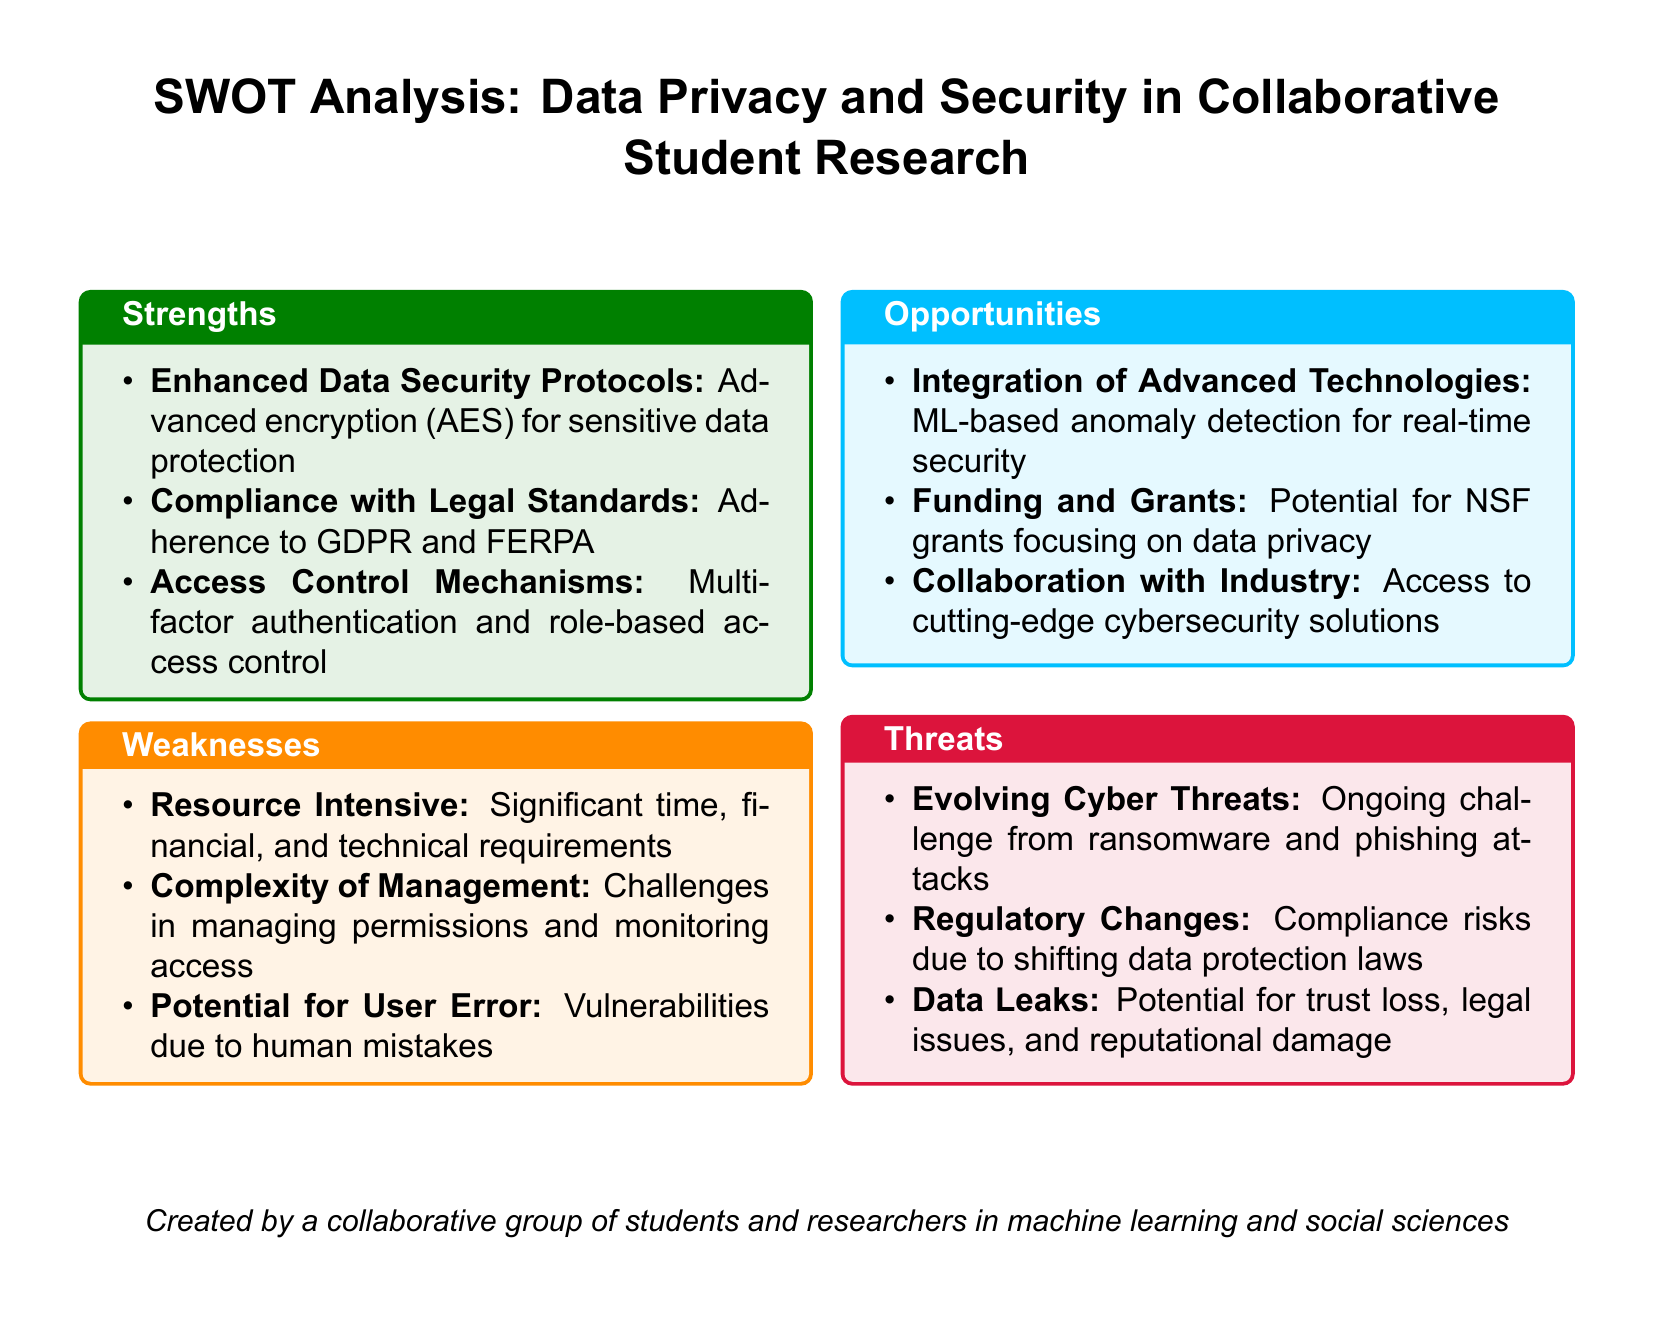what is one of the enhanced data security protocols mentioned? The document lists advanced encryption (AES) as an enhanced data security protocol for sensitive data protection.
Answer: advanced encryption (AES) which two legal standards are mentioned for compliance? The document states adherence to GDPR and FERPA as legal standards.
Answer: GDPR and FERPA what is identified as a potential source of funding? The document mentions potential for NSF grants focusing on data privacy as a funding opportunity.
Answer: NSF grants how are the complexities of management described? It is noted that there are challenges in managing permissions and monitoring access.
Answer: challenges in managing permissions and monitoring access what is one evolving threat highlighted? The document points out ongoing challenges from ransomware as an evolving cyber threat.
Answer: ransomware what type of authentication is mentioned under access control mechanisms? The document describes multi-factor authentication as a part of access control mechanisms.
Answer: multi-factor authentication what is a major weakness regarding resource requirements? The document indicates that implementing these measures is resource-intensive, requiring significant time, financial, and technical resources.
Answer: resource-intensive which technology is suggested for real-time security? Machine learning-based anomaly detection is suggested for real-time security integration.
Answer: ML-based anomaly detection 